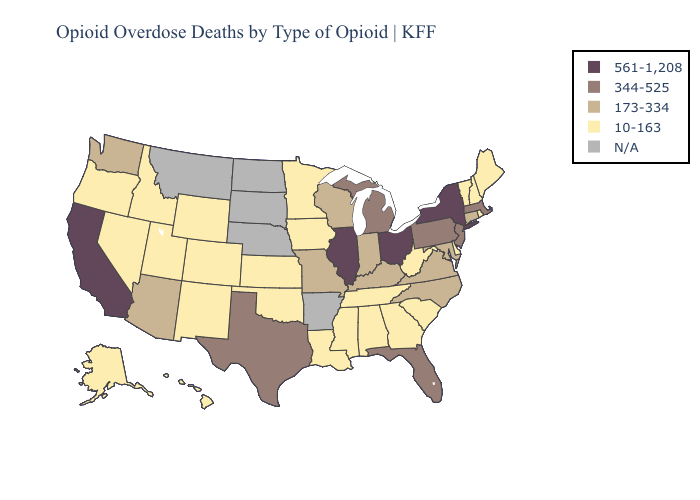What is the highest value in states that border Montana?
Be succinct. 10-163. Does Illinois have the highest value in the USA?
Short answer required. Yes. Does Rhode Island have the highest value in the Northeast?
Give a very brief answer. No. What is the value of Montana?
Short answer required. N/A. Does New York have the highest value in the Northeast?
Give a very brief answer. Yes. What is the value of Arizona?
Answer briefly. 173-334. Name the states that have a value in the range 173-334?
Quick response, please. Arizona, Connecticut, Indiana, Kentucky, Maryland, Missouri, North Carolina, Virginia, Washington, Wisconsin. Does Oklahoma have the lowest value in the South?
Write a very short answer. Yes. Name the states that have a value in the range 344-525?
Keep it brief. Florida, Massachusetts, Michigan, New Jersey, Pennsylvania, Texas. Name the states that have a value in the range 561-1,208?
Concise answer only. California, Illinois, New York, Ohio. Name the states that have a value in the range 561-1,208?
Keep it brief. California, Illinois, New York, Ohio. Which states have the lowest value in the USA?
Keep it brief. Alabama, Alaska, Colorado, Delaware, Georgia, Hawaii, Idaho, Iowa, Kansas, Louisiana, Maine, Minnesota, Mississippi, Nevada, New Hampshire, New Mexico, Oklahoma, Oregon, Rhode Island, South Carolina, Tennessee, Utah, Vermont, West Virginia, Wyoming. 